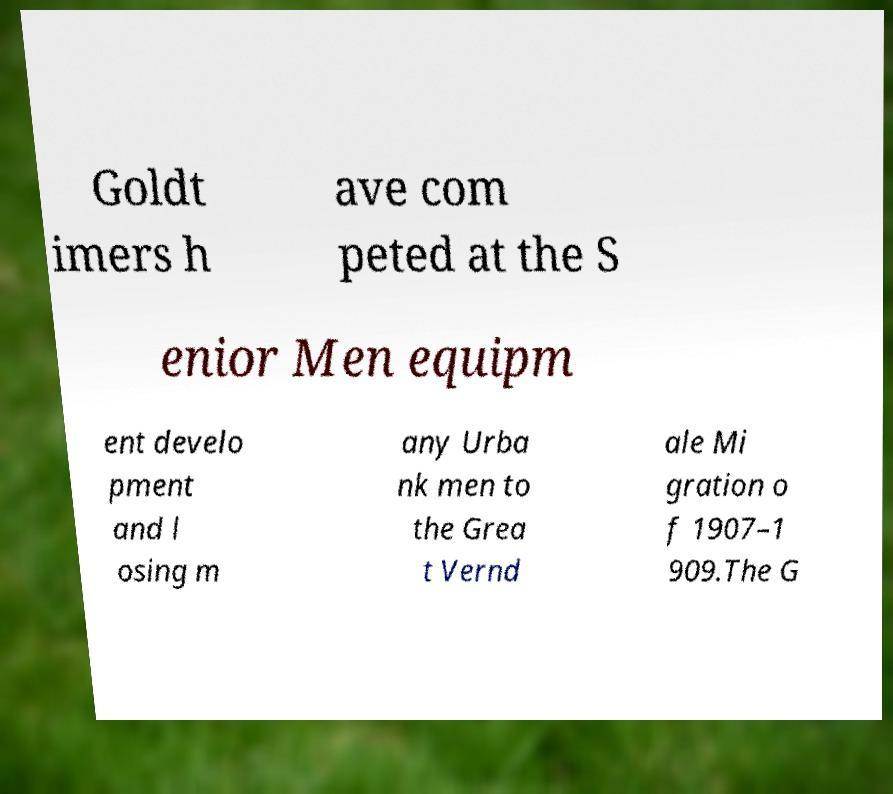Can you accurately transcribe the text from the provided image for me? Goldt imers h ave com peted at the S enior Men equipm ent develo pment and l osing m any Urba nk men to the Grea t Vernd ale Mi gration o f 1907–1 909.The G 